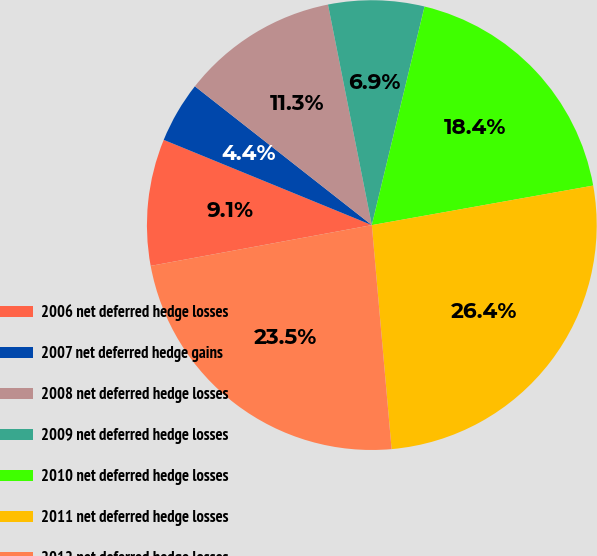Convert chart to OTSL. <chart><loc_0><loc_0><loc_500><loc_500><pie_chart><fcel>2006 net deferred hedge losses<fcel>2007 net deferred hedge gains<fcel>2008 net deferred hedge losses<fcel>2009 net deferred hedge losses<fcel>2010 net deferred hedge losses<fcel>2011 net deferred hedge losses<fcel>2012 net deferred hedge losses<nl><fcel>9.09%<fcel>4.4%<fcel>11.29%<fcel>6.89%<fcel>18.42%<fcel>26.41%<fcel>23.5%<nl></chart> 